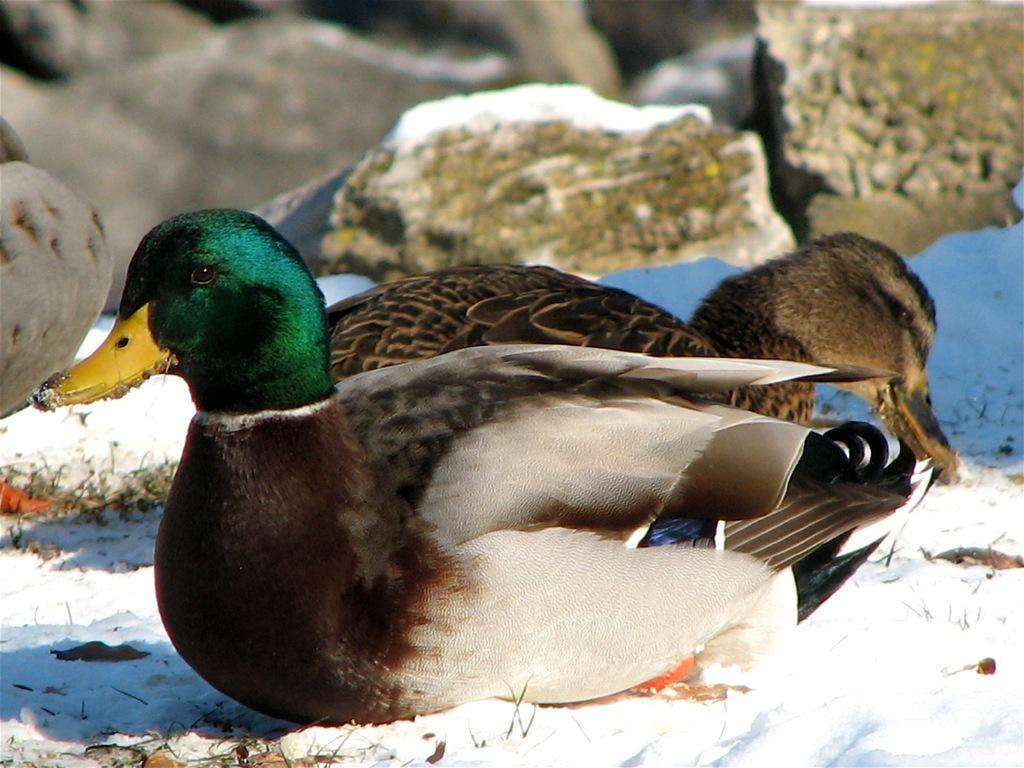What type of animals can be seen in the image? There are birds in the image. What is visible in the background of the image? There is snow and stones visible in the background of the image. What type of hope can be seen in the image? There is no reference to hope in the image; it features birds and a snowy background with stones. 